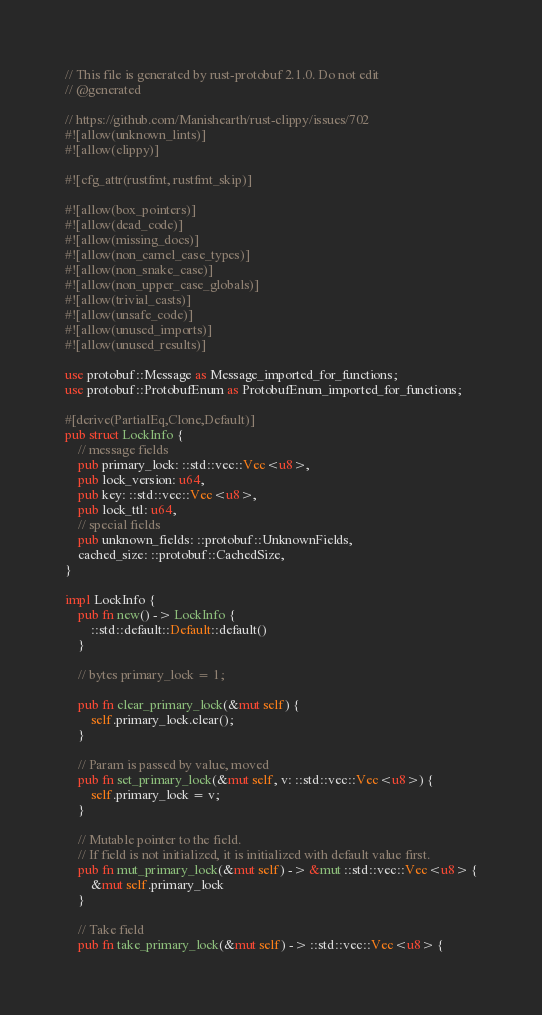Convert code to text. <code><loc_0><loc_0><loc_500><loc_500><_Rust_>// This file is generated by rust-protobuf 2.1.0. Do not edit
// @generated

// https://github.com/Manishearth/rust-clippy/issues/702
#![allow(unknown_lints)]
#![allow(clippy)]

#![cfg_attr(rustfmt, rustfmt_skip)]

#![allow(box_pointers)]
#![allow(dead_code)]
#![allow(missing_docs)]
#![allow(non_camel_case_types)]
#![allow(non_snake_case)]
#![allow(non_upper_case_globals)]
#![allow(trivial_casts)]
#![allow(unsafe_code)]
#![allow(unused_imports)]
#![allow(unused_results)]

use protobuf::Message as Message_imported_for_functions;
use protobuf::ProtobufEnum as ProtobufEnum_imported_for_functions;

#[derive(PartialEq,Clone,Default)]
pub struct LockInfo {
    // message fields
    pub primary_lock: ::std::vec::Vec<u8>,
    pub lock_version: u64,
    pub key: ::std::vec::Vec<u8>,
    pub lock_ttl: u64,
    // special fields
    pub unknown_fields: ::protobuf::UnknownFields,
    cached_size: ::protobuf::CachedSize,
}

impl LockInfo {
    pub fn new() -> LockInfo {
        ::std::default::Default::default()
    }

    // bytes primary_lock = 1;

    pub fn clear_primary_lock(&mut self) {
        self.primary_lock.clear();
    }

    // Param is passed by value, moved
    pub fn set_primary_lock(&mut self, v: ::std::vec::Vec<u8>) {
        self.primary_lock = v;
    }

    // Mutable pointer to the field.
    // If field is not initialized, it is initialized with default value first.
    pub fn mut_primary_lock(&mut self) -> &mut ::std::vec::Vec<u8> {
        &mut self.primary_lock
    }

    // Take field
    pub fn take_primary_lock(&mut self) -> ::std::vec::Vec<u8> {</code> 